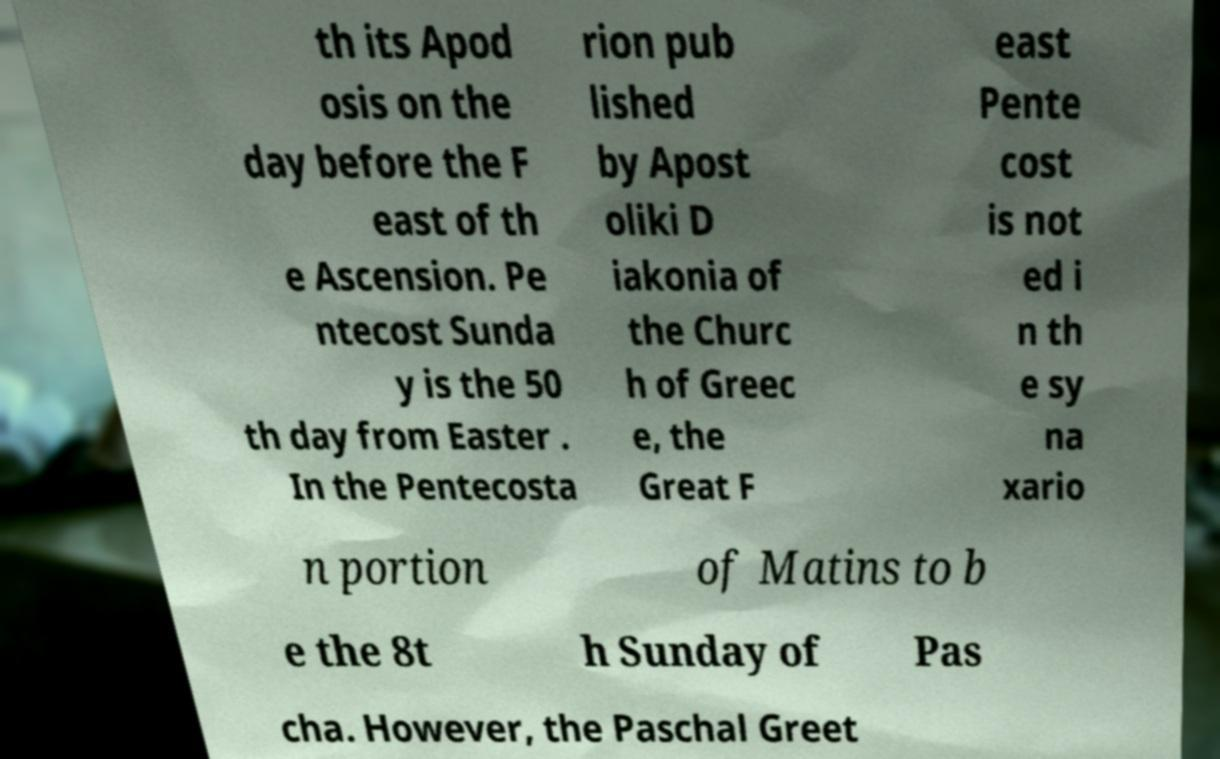Could you assist in decoding the text presented in this image and type it out clearly? th its Apod osis on the day before the F east of th e Ascension. Pe ntecost Sunda y is the 50 th day from Easter . In the Pentecosta rion pub lished by Apost oliki D iakonia of the Churc h of Greec e, the Great F east Pente cost is not ed i n th e sy na xario n portion of Matins to b e the 8t h Sunday of Pas cha. However, the Paschal Greet 